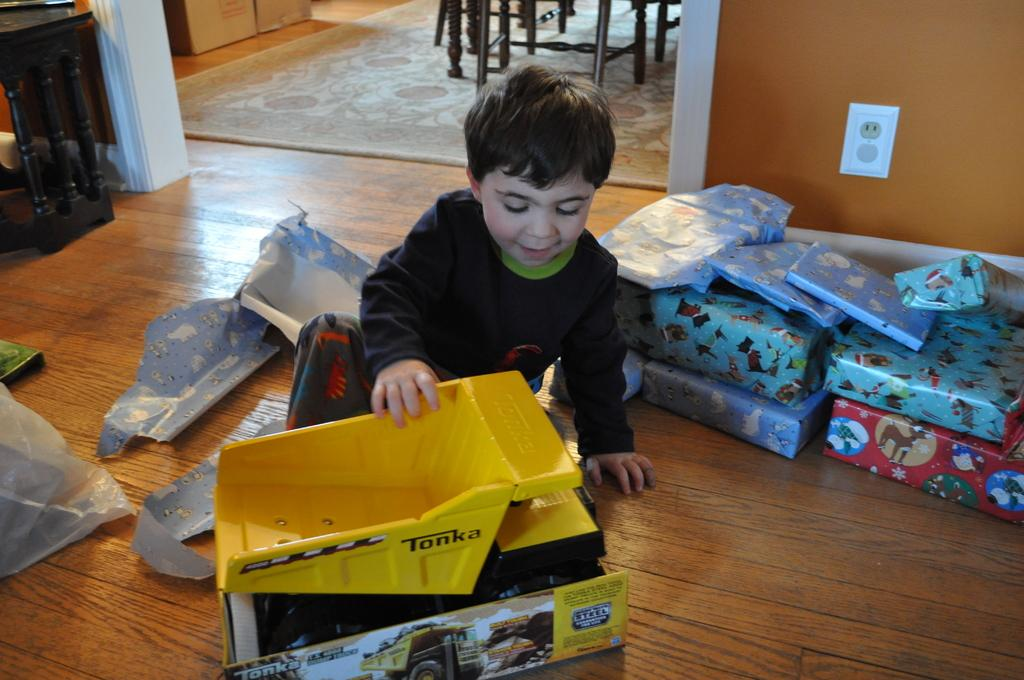Who is the main subject in the image? There is a boy in the image. What is the boy doing in the image? The boy is playing with toys. What type of clothing is the boy wearing on his upper body? The boy is wearing a t-shirt. What type of clothing is the boy wearing on his lower body? The boy is wearing trousers. What type of sticks can be seen in the boy's wrist in the image? There are no sticks visible in the image, and the boy's wrist is not mentioned in the provided facts. 